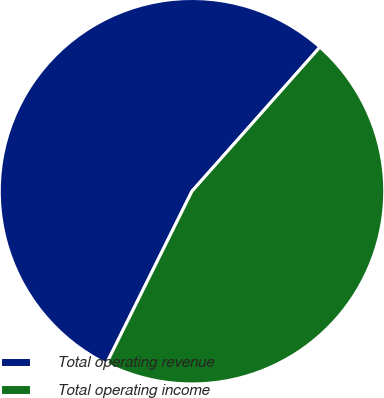Convert chart. <chart><loc_0><loc_0><loc_500><loc_500><pie_chart><fcel>Total operating revenue<fcel>Total operating income<nl><fcel>54.22%<fcel>45.78%<nl></chart> 